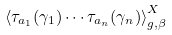<formula> <loc_0><loc_0><loc_500><loc_500>\left \langle \tau _ { a _ { 1 } } ( \gamma _ { 1 } ) \cdots \tau _ { a _ { n } } ( \gamma _ { n } ) \right \rangle ^ { X } _ { g , \beta }</formula> 